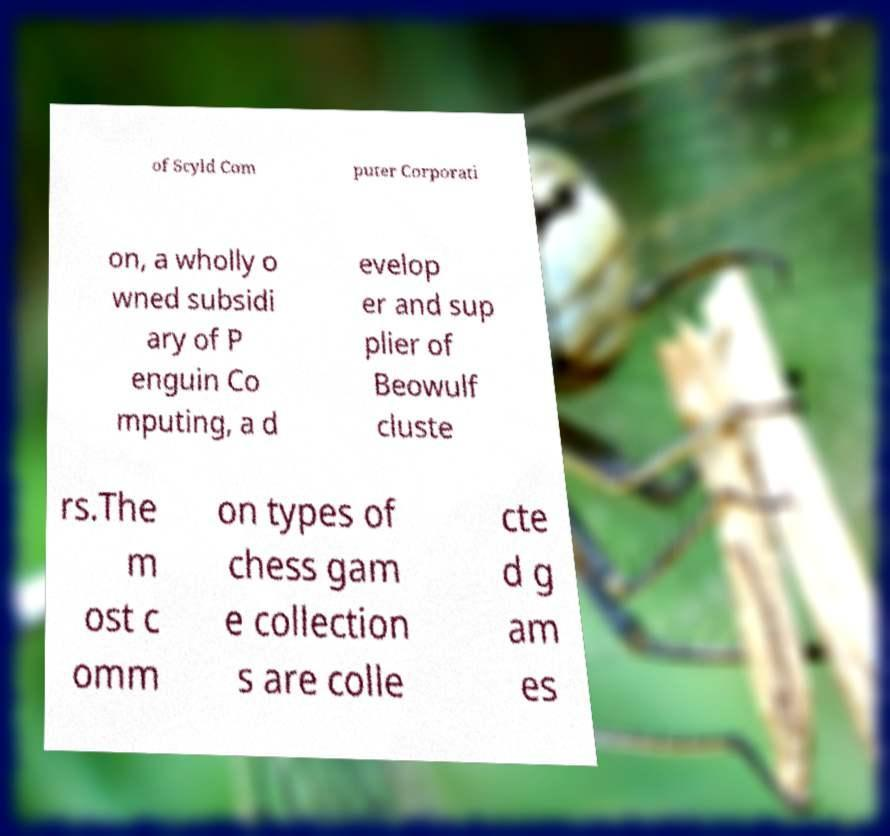Please read and relay the text visible in this image. What does it say? of Scyld Com puter Corporati on, a wholly o wned subsidi ary of P enguin Co mputing, a d evelop er and sup plier of Beowulf cluste rs.The m ost c omm on types of chess gam e collection s are colle cte d g am es 